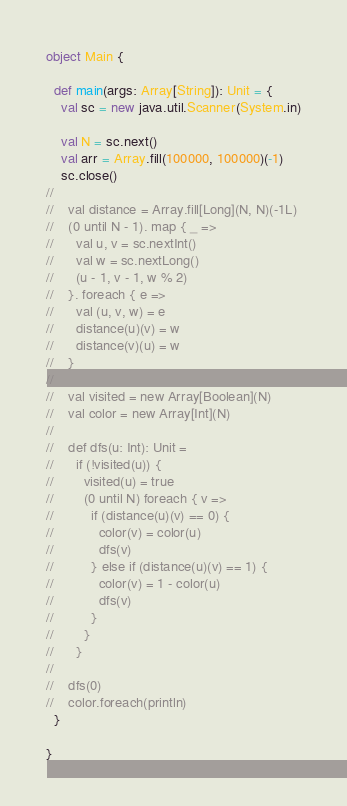Convert code to text. <code><loc_0><loc_0><loc_500><loc_500><_Scala_>object Main {

  def main(args: Array[String]): Unit = {
    val sc = new java.util.Scanner(System.in)

    val N = sc.next()
    val arr = Array.fill(100000, 100000)(-1)
    sc.close()
//
//    val distance = Array.fill[Long](N, N)(-1L)
//    (0 until N - 1). map { _ =>
//      val u, v = sc.nextInt()
//      val w = sc.nextLong()
//      (u - 1, v - 1, w % 2)
//    }. foreach { e =>
//      val (u, v, w) = e
//      distance(u)(v) = w
//      distance(v)(u) = w
//    }
//
//    val visited = new Array[Boolean](N)
//    val color = new Array[Int](N)
//
//    def dfs(u: Int): Unit =
//      if (!visited(u)) {
//        visited(u) = true
//        (0 until N) foreach { v =>
//          if (distance(u)(v) == 0) {
//            color(v) = color(u)
//            dfs(v)
//          } else if (distance(u)(v) == 1) {
//            color(v) = 1 - color(u)
//            dfs(v)
//          }
//        }
//      }
//
//    dfs(0)
//    color.foreach(println)
  }

}
</code> 